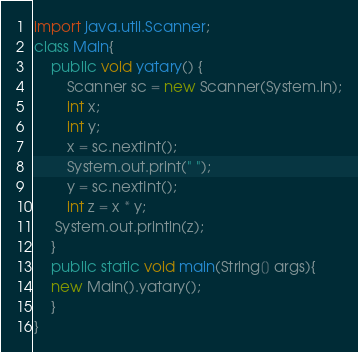<code> <loc_0><loc_0><loc_500><loc_500><_Java_>import java.util.Scanner;
class Main{
    public void yatary() {
        Scanner sc = new Scanner(System.in);
        int x;
        int y;
        x = sc.nextInt();
        System.out.print(" ");
        y = sc.nextInt();
        int z = x * y;
     System.out.println(z);   
    }
    public static void main(String[] args){
    new Main().yatary();
    }
}</code> 